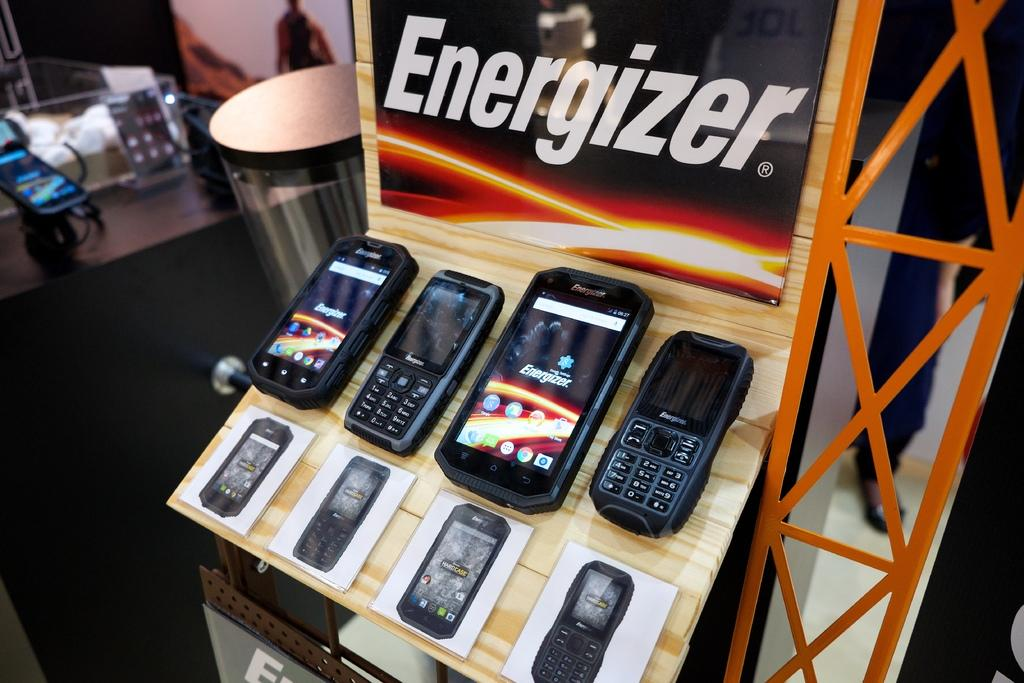<image>
Relay a brief, clear account of the picture shown. A display of new phones with a sign above that says Energizer. 